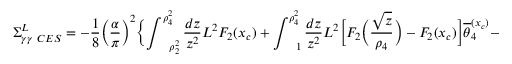Convert formula to latex. <formula><loc_0><loc_0><loc_500><loc_500>\Sigma _ { \gamma \gamma \ C E S } ^ { L } = - \frac { 1 } { 8 } \Big ( \frac { \alpha } { \pi } \Big ) ^ { 2 } \Big \{ \int _ { \quad r h o _ { 2 } ^ { 2 } } ^ { \rho _ { 4 } ^ { 2 } } \frac { d z } { z ^ { 2 } } L ^ { 2 } F _ { 2 } ( x _ { c } ) + \int _ { \quad 1 } ^ { \rho _ { 4 } ^ { 2 } } \frac { d z } { z ^ { 2 } } L ^ { 2 } \Big [ F _ { 2 } \Big ( \frac { \sqrt { z } } { \rho _ { 4 } } \Big ) - F _ { 2 } ( x _ { c } ) \Big ] \overline { \theta } _ { 4 } ^ { ( x _ { c } ) } -</formula> 